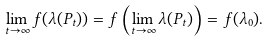<formula> <loc_0><loc_0><loc_500><loc_500>\lim _ { t \rightarrow \infty } f ( \lambda ( P _ { t } ) ) = f \left ( \lim _ { t \rightarrow \infty } \lambda ( P _ { t } ) \right ) = f ( \lambda _ { 0 } ) .</formula> 